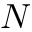Convert formula to latex. <formula><loc_0><loc_0><loc_500><loc_500>N</formula> 